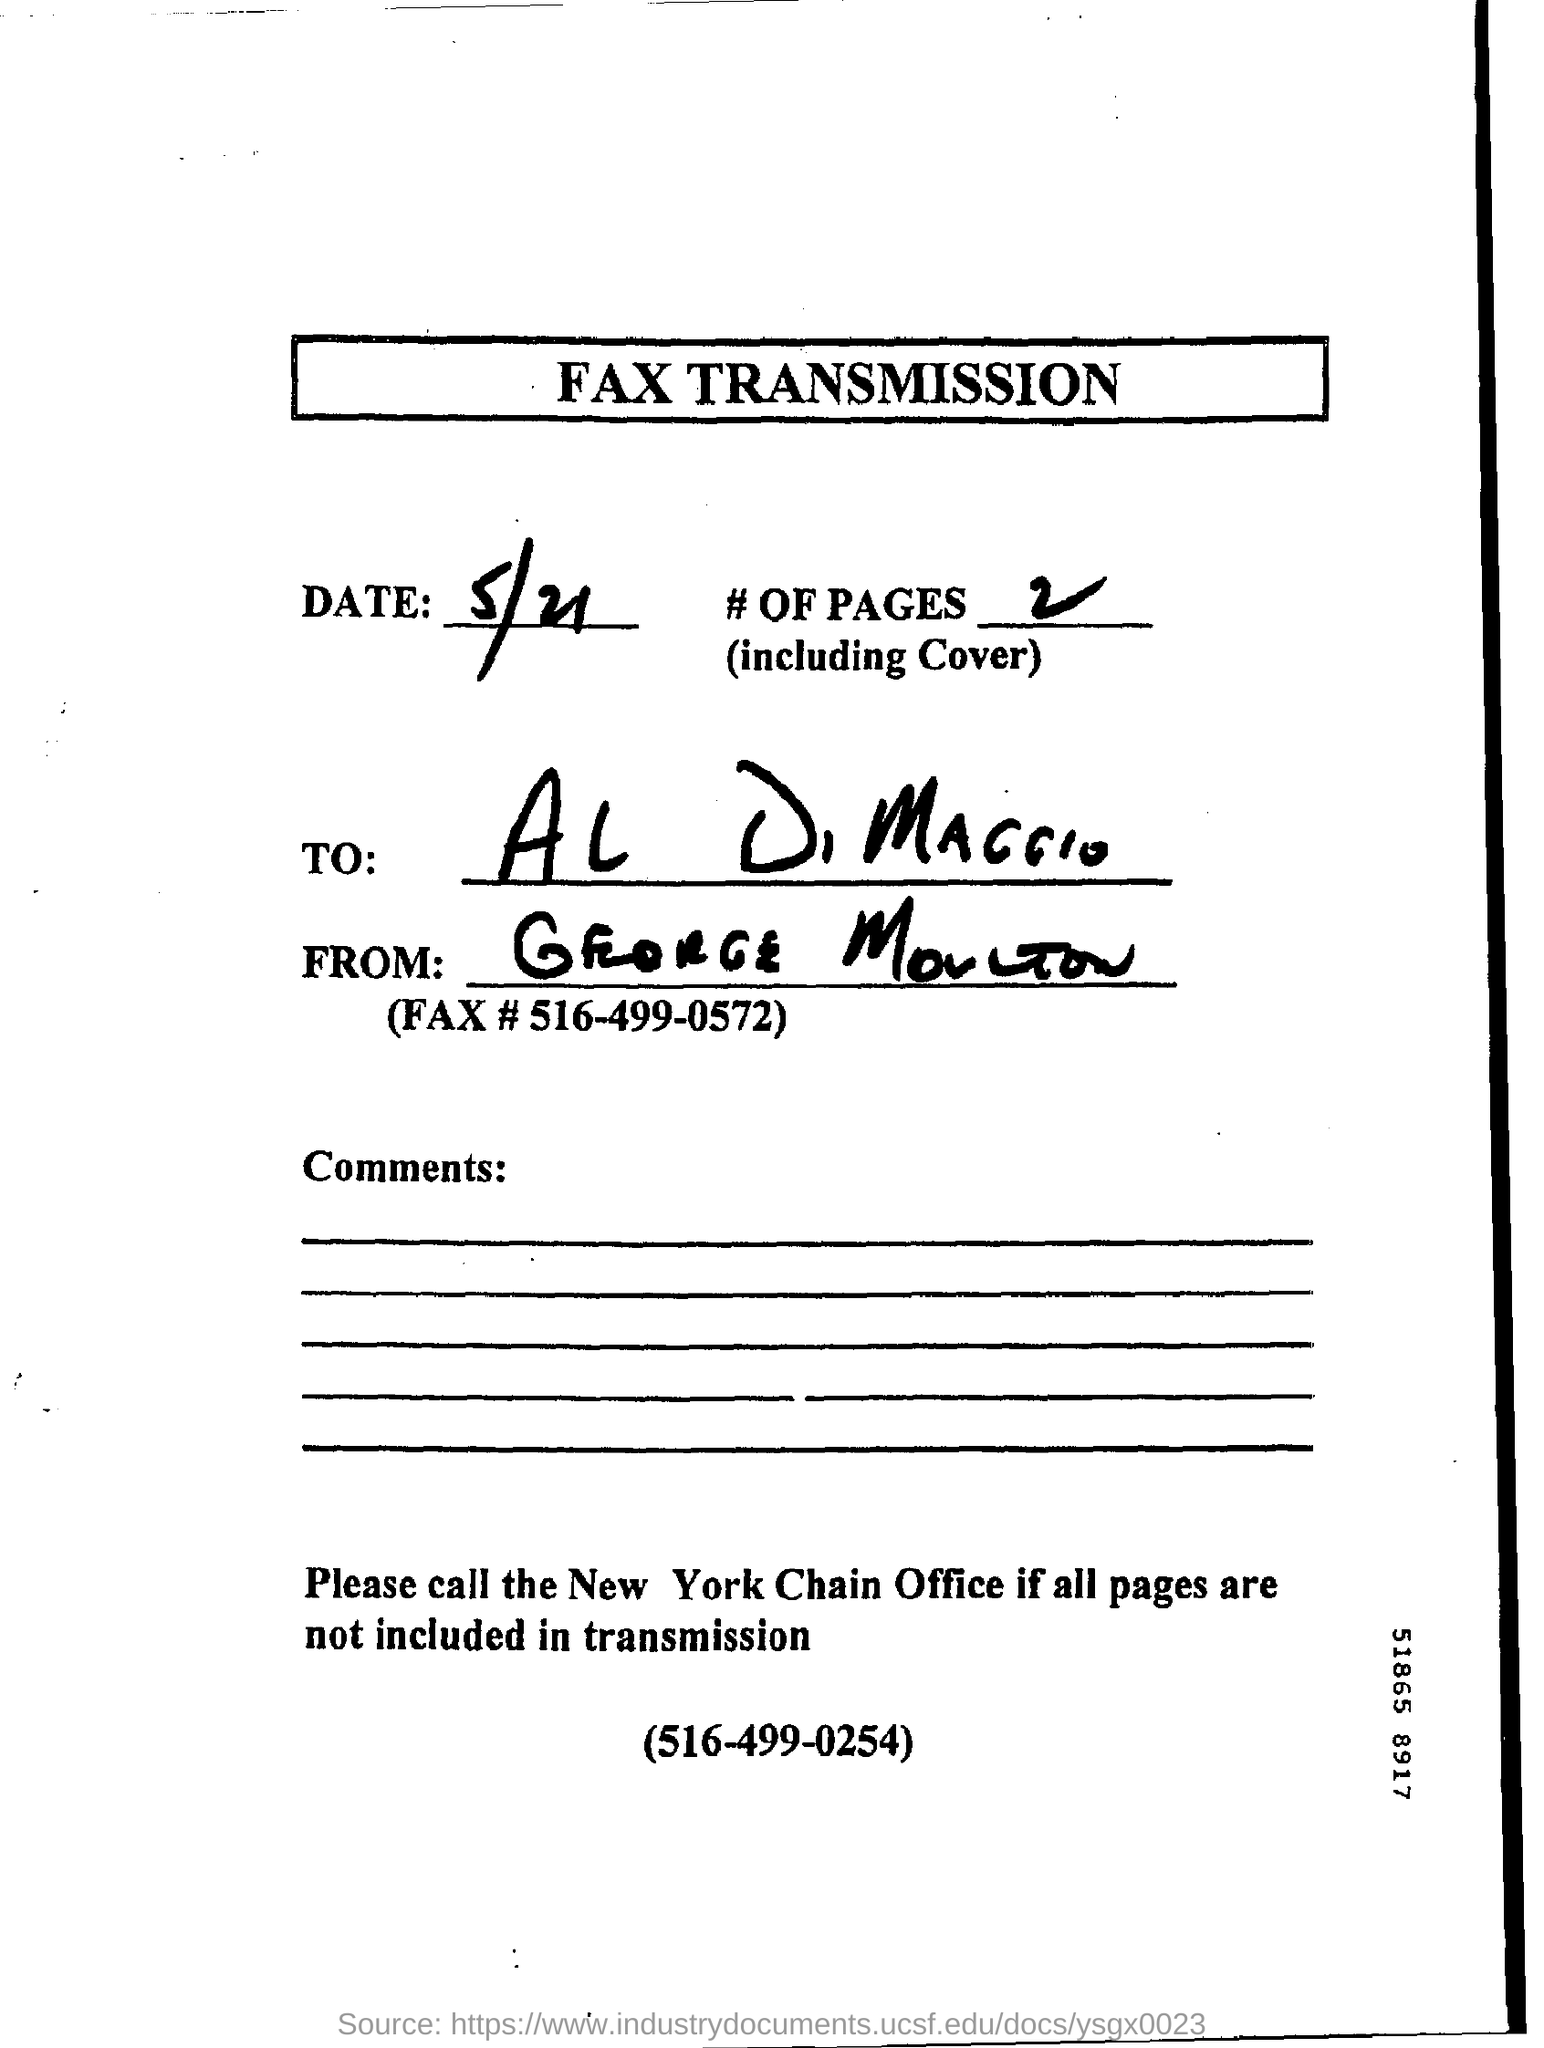What is the Title of the document?
Your response must be concise. FAX TRANSMISSION. What is the Date?
Keep it short and to the point. 5/21. What are the # of pages?
Your answer should be compact. 2. Who is it addressed to?
Provide a short and direct response. AL DIMAGGIO. What is the Fax # in the document?
Keep it short and to the point. 516-499-0572. 